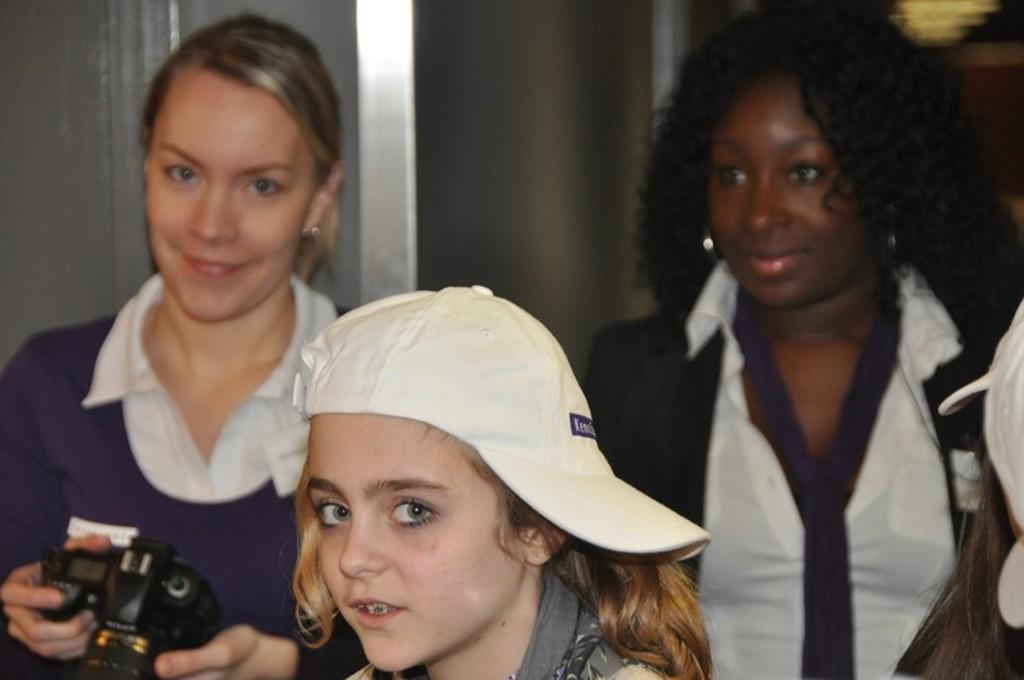How many women are in the image? There are two women in the image. What are the women doing in the image? The women are standing and smiling. Can you describe the actions of one of the women? One woman is staring and holding a camera. What is the other woman wearing? The other woman is wearing a white cap. What day of the week is depicted in the image? The day of the week is not mentioned or depicted in the image. Who is the writer in the image? There is no writer present in the image. 